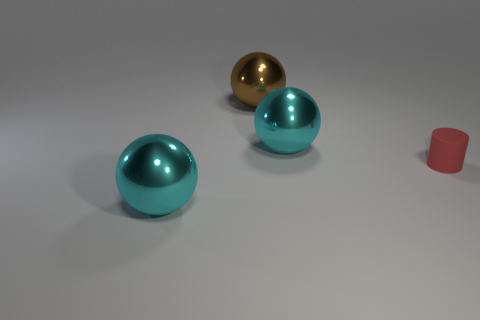Is there a purple shiny cube?
Your answer should be very brief. No. Is the number of brown metallic spheres that are in front of the brown object greater than the number of large brown things that are on the left side of the tiny red rubber cylinder?
Make the answer very short. No. Is there any other thing that has the same size as the brown sphere?
Ensure brevity in your answer.  Yes. Is the color of the sphere that is right of the big brown sphere the same as the big metallic sphere that is in front of the tiny red rubber thing?
Your response must be concise. Yes. What is the shape of the red matte thing?
Make the answer very short. Cylinder. Is the number of large cyan things that are to the right of the red rubber thing greater than the number of large metallic balls?
Provide a succinct answer. No. There is a large cyan thing that is behind the small red rubber cylinder; what shape is it?
Make the answer very short. Sphere. What number of other objects are there of the same shape as the tiny thing?
Ensure brevity in your answer.  0. Are the large brown sphere to the left of the red rubber cylinder and the red object made of the same material?
Offer a very short reply. No. Are there an equal number of big brown things that are behind the tiny red rubber cylinder and big brown things on the right side of the big brown thing?
Provide a short and direct response. No. 